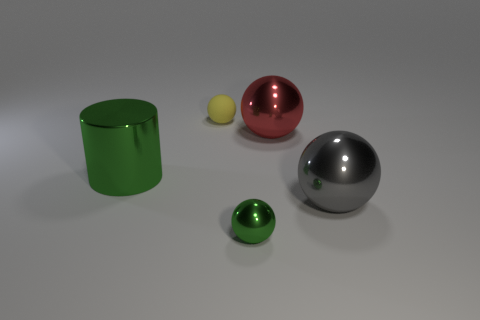Are there any other things that are the same shape as the big green metal thing?
Make the answer very short. No. Is the number of shiny cylinders behind the metallic cylinder the same as the number of green metal things?
Offer a very short reply. No. Is the material of the small green ball the same as the yellow thing?
Make the answer very short. No. How big is the object that is both on the left side of the red shiny ball and to the right of the tiny yellow rubber ball?
Ensure brevity in your answer.  Small. How many metal cubes are the same size as the red metal object?
Your answer should be compact. 0. What size is the metal sphere that is behind the large thing that is to the left of the yellow ball?
Offer a terse response. Large. Do the small thing behind the small green metallic thing and the tiny object that is in front of the big red sphere have the same shape?
Offer a very short reply. Yes. What color is the sphere that is in front of the tiny rubber thing and to the left of the red sphere?
Your answer should be compact. Green. Are there any large objects that have the same color as the tiny metallic sphere?
Give a very brief answer. Yes. The small ball behind the green sphere is what color?
Keep it short and to the point. Yellow. 